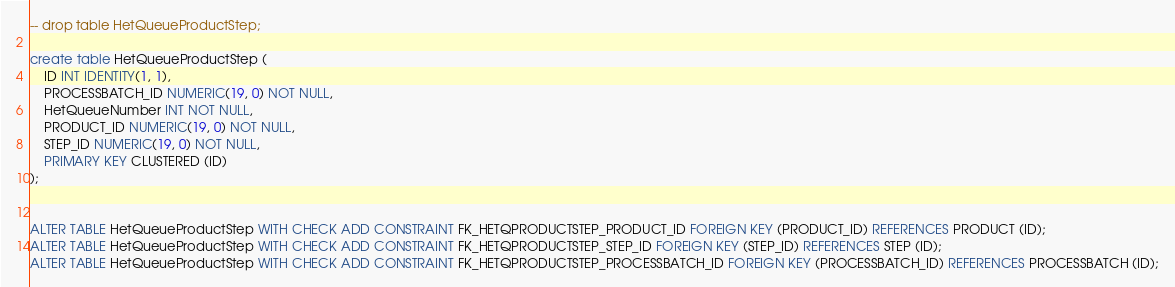Convert code to text. <code><loc_0><loc_0><loc_500><loc_500><_SQL_>-- drop table HetQueueProductStep;

create table HetQueueProductStep (
	ID INT IDENTITY(1, 1),
	PROCESSBATCH_ID NUMERIC(19, 0) NOT NULL,
	HetQueueNumber INT NOT NULL,
	PRODUCT_ID NUMERIC(19, 0) NOT NULL,
	STEP_ID NUMERIC(19, 0) NOT NULL,
	PRIMARY KEY CLUSTERED (ID)
);


ALTER TABLE HetQueueProductStep WITH CHECK ADD CONSTRAINT FK_HETQPRODUCTSTEP_PRODUCT_ID FOREIGN KEY (PRODUCT_ID) REFERENCES PRODUCT (ID);
ALTER TABLE HetQueueProductStep WITH CHECK ADD CONSTRAINT FK_HETQPRODUCTSTEP_STEP_ID FOREIGN KEY (STEP_ID) REFERENCES STEP (ID);
ALTER TABLE HetQueueProductStep WITH CHECK ADD CONSTRAINT FK_HETQPRODUCTSTEP_PROCESSBATCH_ID FOREIGN KEY (PROCESSBATCH_ID) REFERENCES PROCESSBATCH (ID);


</code> 